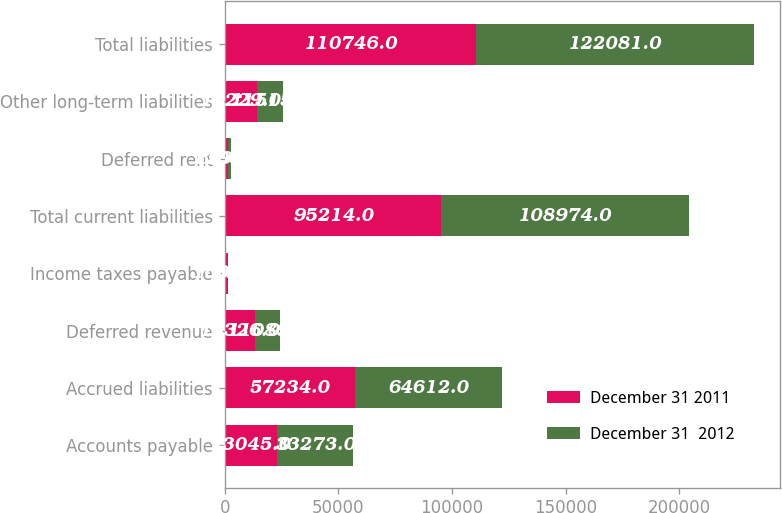<chart> <loc_0><loc_0><loc_500><loc_500><stacked_bar_chart><ecel><fcel>Accounts payable<fcel>Accrued liabilities<fcel>Deferred revenue<fcel>Income taxes payable<fcel>Total current liabilities<fcel>Deferred rent<fcel>Other long-term liabilities<fcel>Total liabilities<nl><fcel>December 31 2011<fcel>23045<fcel>57234<fcel>13326<fcel>1609<fcel>95214<fcel>1303<fcel>14229<fcel>110746<nl><fcel>December 31  2012<fcel>33273<fcel>64612<fcel>11089<fcel>0<fcel>108974<fcel>1592<fcel>11515<fcel>122081<nl></chart> 